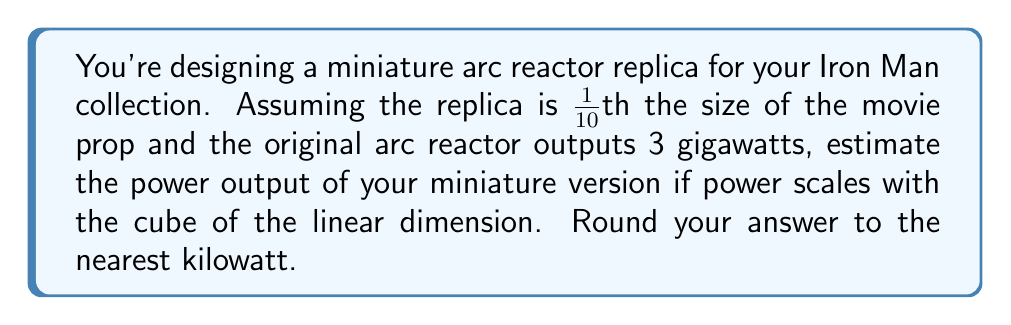Can you answer this question? Let's approach this step-by-step:

1) First, we need to understand the scaling relationship. If power scales with the cube of the linear dimension, we can express this as:

   $$\frac{P_2}{P_1} = \left(\frac{L_2}{L_1}\right)^3$$

   Where $P$ is power and $L$ is the linear dimension.

2) We're given that the replica is 1/10th the size of the original, so:

   $$\frac{L_2}{L_1} = \frac{1}{10}$$

3) We're also given that the original power output is 3 gigawatts:

   $$P_1 = 3 \text{ GW} = 3 \times 10^9 \text{ W}$$

4) Now, let's substitute these into our scaling equation:

   $$\frac{P_2}{3 \times 10^9} = \left(\frac{1}{10}\right)^3$$

5) Simplify the right side:

   $$\frac{P_2}{3 \times 10^9} = \frac{1}{1000}$$

6) Solve for $P_2$:

   $$P_2 = 3 \times 10^9 \times \frac{1}{1000} = 3 \times 10^6 \text{ W} = 3000 \text{ kW}$$

7) Rounding to the nearest kilowatt:

   $$P_2 \approx 3000 \text{ kW}$$
Answer: 3000 kW 